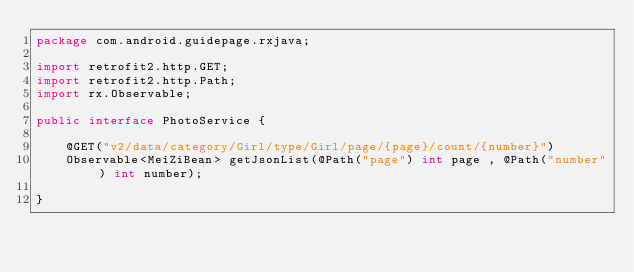Convert code to text. <code><loc_0><loc_0><loc_500><loc_500><_Java_>package com.android.guidepage.rxjava;

import retrofit2.http.GET;
import retrofit2.http.Path;
import rx.Observable;

public interface PhotoService {

    @GET("v2/data/category/Girl/type/Girl/page/{page}/count/{number}")
    Observable<MeiZiBean> getJsonList(@Path("page") int page , @Path("number") int number);

}
</code> 